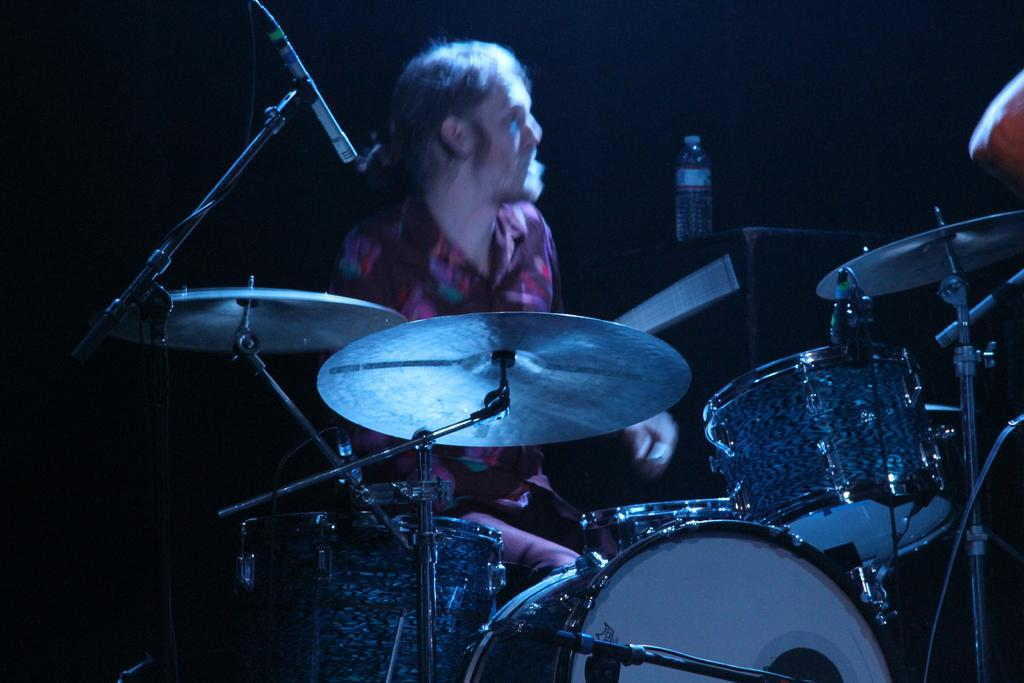Who is the main subject in the image? There is a man in the image. What is the man wearing? The man is wearing a red shirt. What activity is the man engaged in? The man is playing drums. What object is beside the man? There is a bottle beside the man. What color is the background of the image? The background of the image is black. How does the man's partner feel about his drumming skills in the image? There is no indication of a partner or their feelings in the image. 